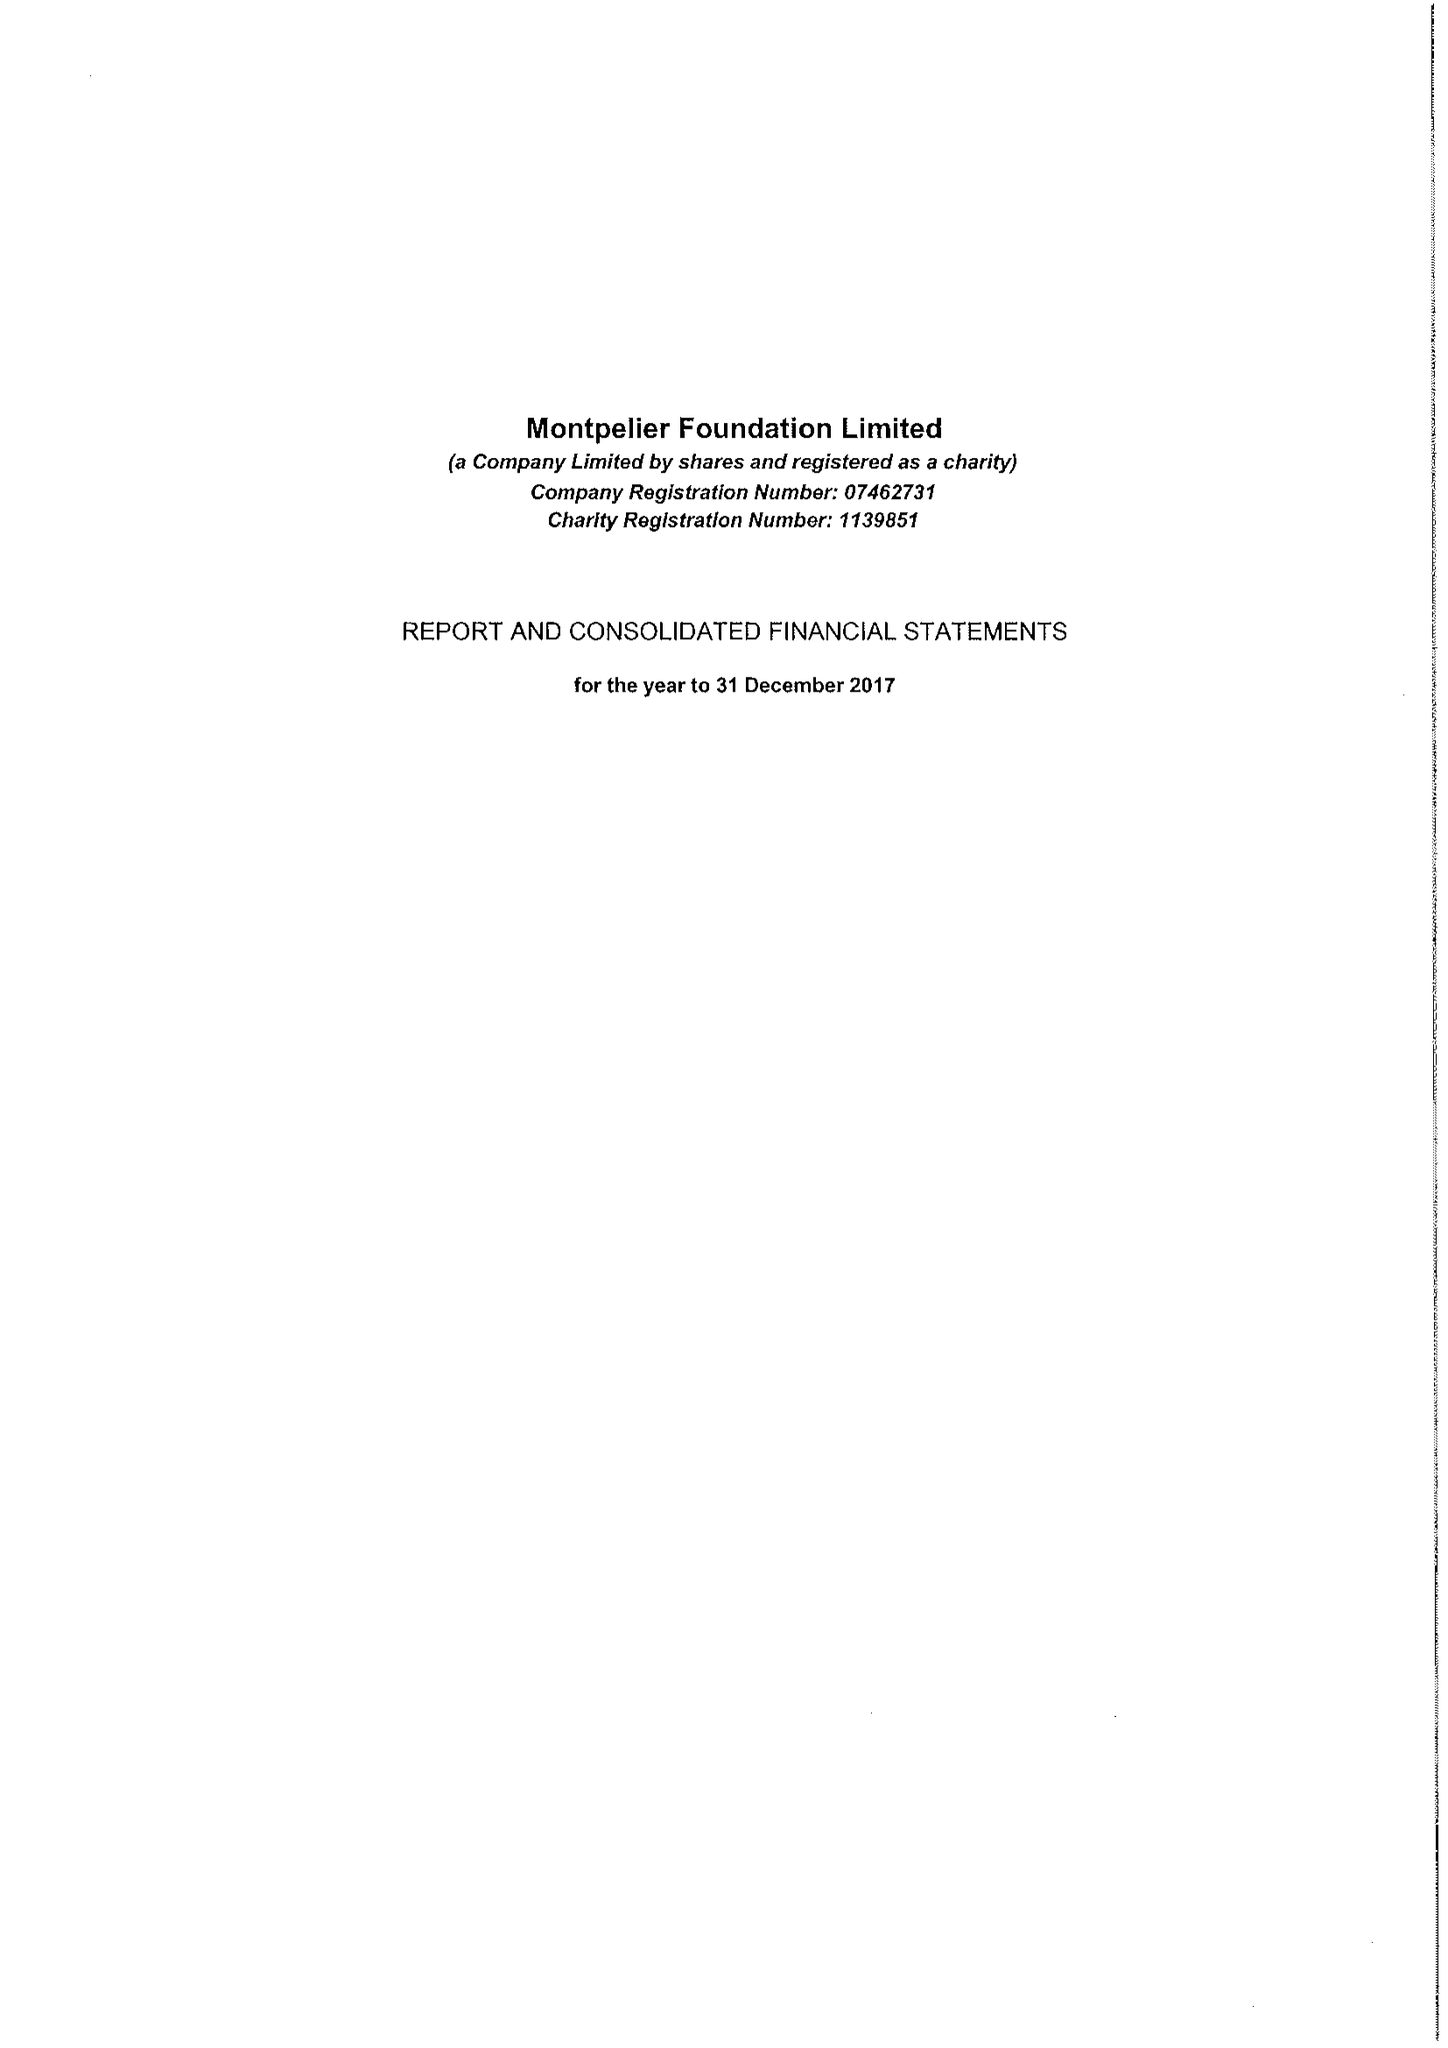What is the value for the spending_annually_in_british_pounds?
Answer the question using a single word or phrase. 1099438.00 